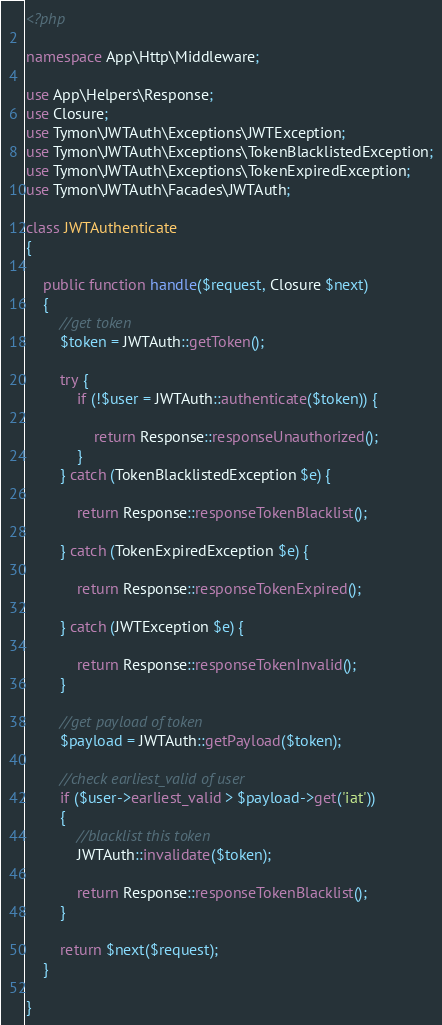Convert code to text. <code><loc_0><loc_0><loc_500><loc_500><_PHP_><?php

namespace App\Http\Middleware;

use App\Helpers\Response;
use Closure;
use Tymon\JWTAuth\Exceptions\JWTException;
use Tymon\JWTAuth\Exceptions\TokenBlacklistedException;
use Tymon\JWTAuth\Exceptions\TokenExpiredException;
use Tymon\JWTAuth\Facades\JWTAuth;

class JWTAuthenticate
{

    public function handle($request, Closure $next)
    {
        //get token
        $token = JWTAuth::getToken();

        try {
            if (!$user = JWTAuth::authenticate($token)) {

                return Response::responseUnauthorized();
            }
        } catch (TokenBlacklistedException $e) {

            return Response::responseTokenBlacklist();

        } catch (TokenExpiredException $e) {

            return Response::responseTokenExpired();

        } catch (JWTException $e) {

            return Response::responseTokenInvalid();
        }

        //get payload of token
        $payload = JWTAuth::getPayload($token);

        //check earliest_valid of user
        if ($user->earliest_valid > $payload->get('iat'))
        {
            //blacklist this token
            JWTAuth::invalidate($token);

            return Response::responseTokenBlacklist();
        }

        return $next($request);
    }

}
</code> 